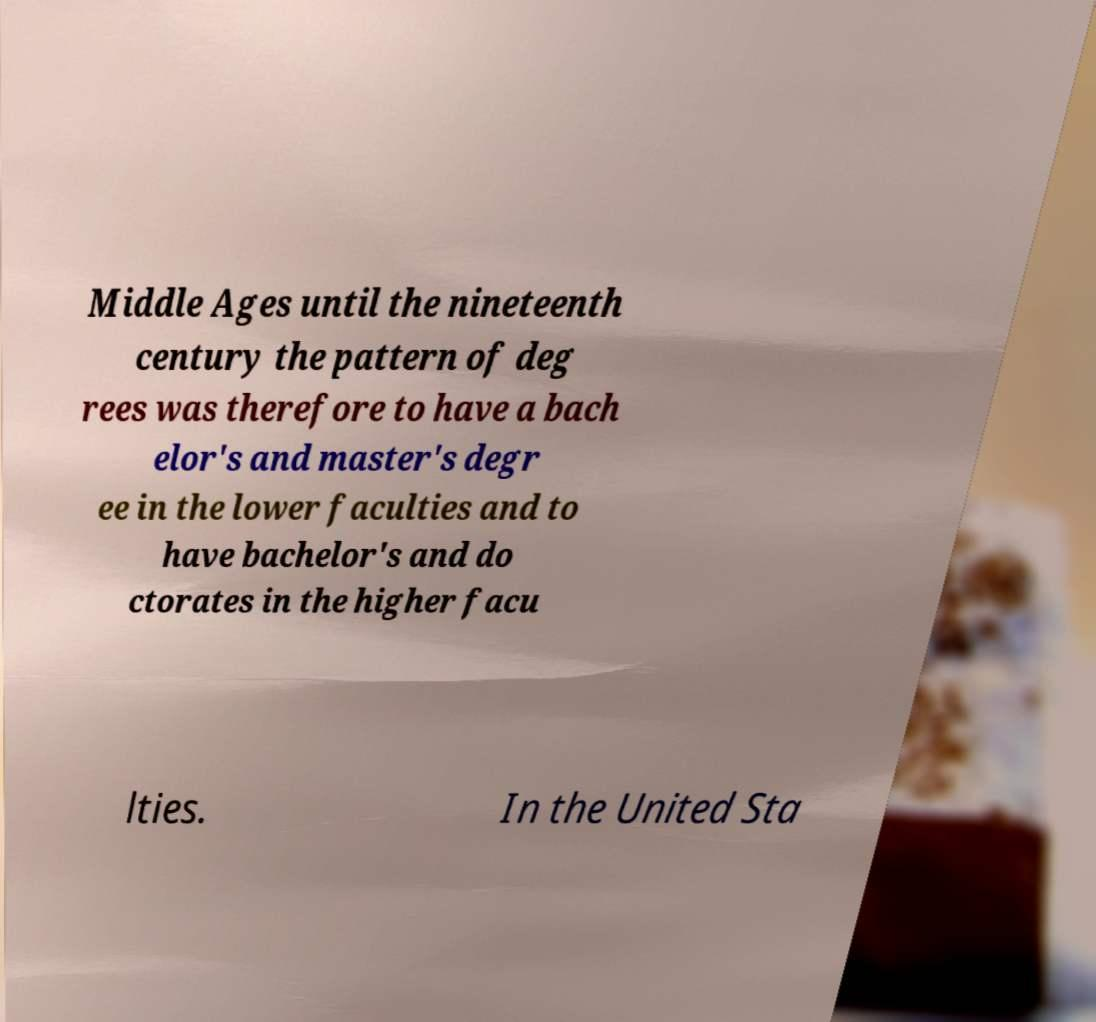Could you assist in decoding the text presented in this image and type it out clearly? Middle Ages until the nineteenth century the pattern of deg rees was therefore to have a bach elor's and master's degr ee in the lower faculties and to have bachelor's and do ctorates in the higher facu lties. In the United Sta 